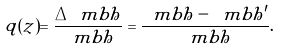Convert formula to latex. <formula><loc_0><loc_0><loc_500><loc_500>q ( z ) = \frac { \Delta \ m b h } { \ m b h } = \frac { \ m b h - \ m b h ^ { \prime } } { \ m b h } .</formula> 